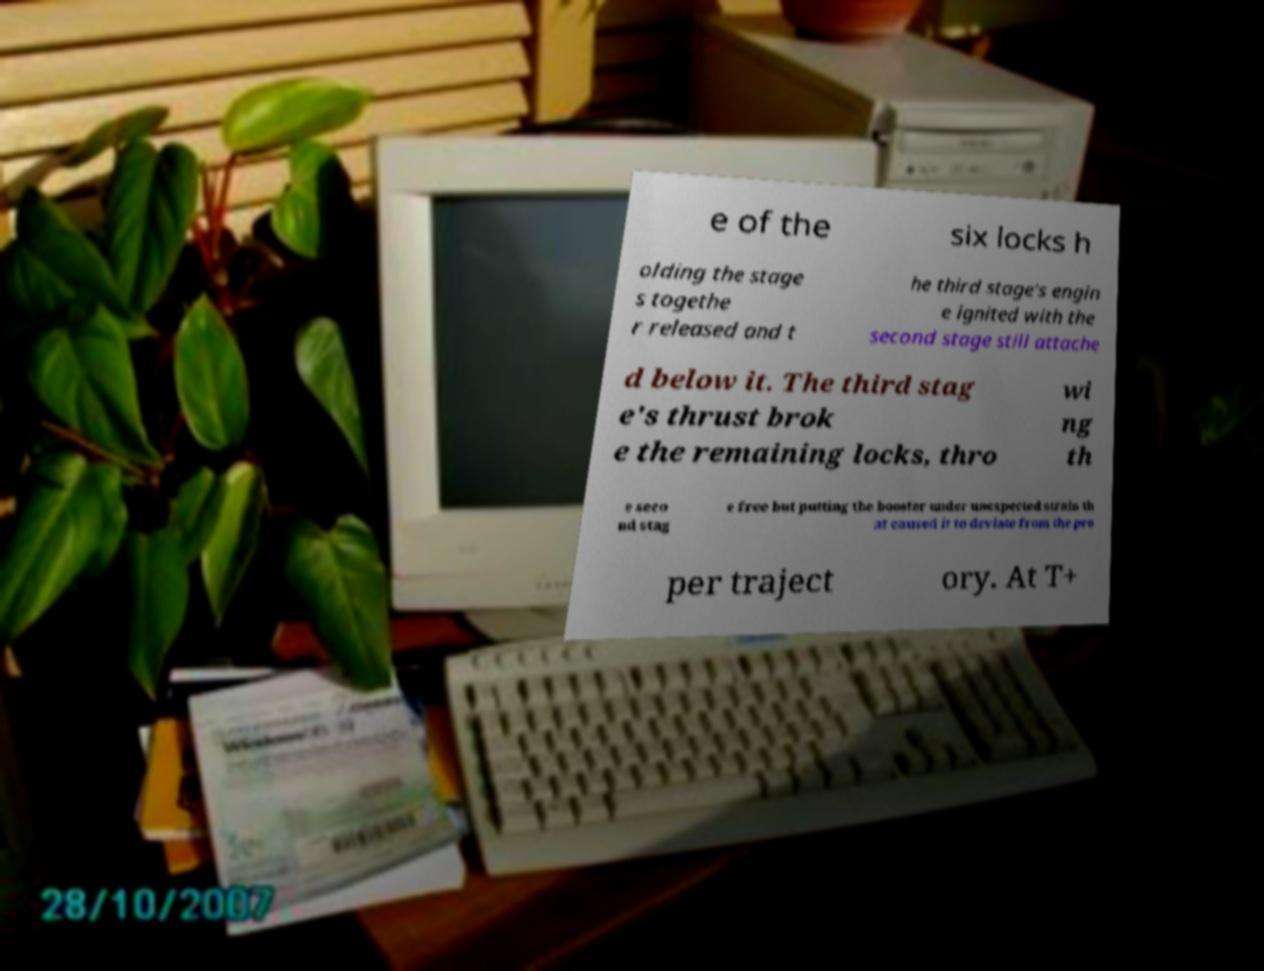Could you assist in decoding the text presented in this image and type it out clearly? e of the six locks h olding the stage s togethe r released and t he third stage's engin e ignited with the second stage still attache d below it. The third stag e's thrust brok e the remaining locks, thro wi ng th e seco nd stag e free but putting the booster under unexpected strain th at caused it to deviate from the pro per traject ory. At T+ 